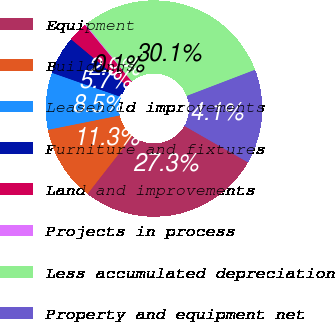<chart> <loc_0><loc_0><loc_500><loc_500><pie_chart><fcel>Equipment<fcel>Buildings<fcel>Leasehold improvements<fcel>Furniture and fixtures<fcel>Land and improvements<fcel>Projects in process<fcel>Less accumulated depreciation<fcel>Property and equipment net<nl><fcel>27.26%<fcel>11.31%<fcel>8.51%<fcel>5.72%<fcel>2.92%<fcel>0.13%<fcel>30.05%<fcel>14.1%<nl></chart> 